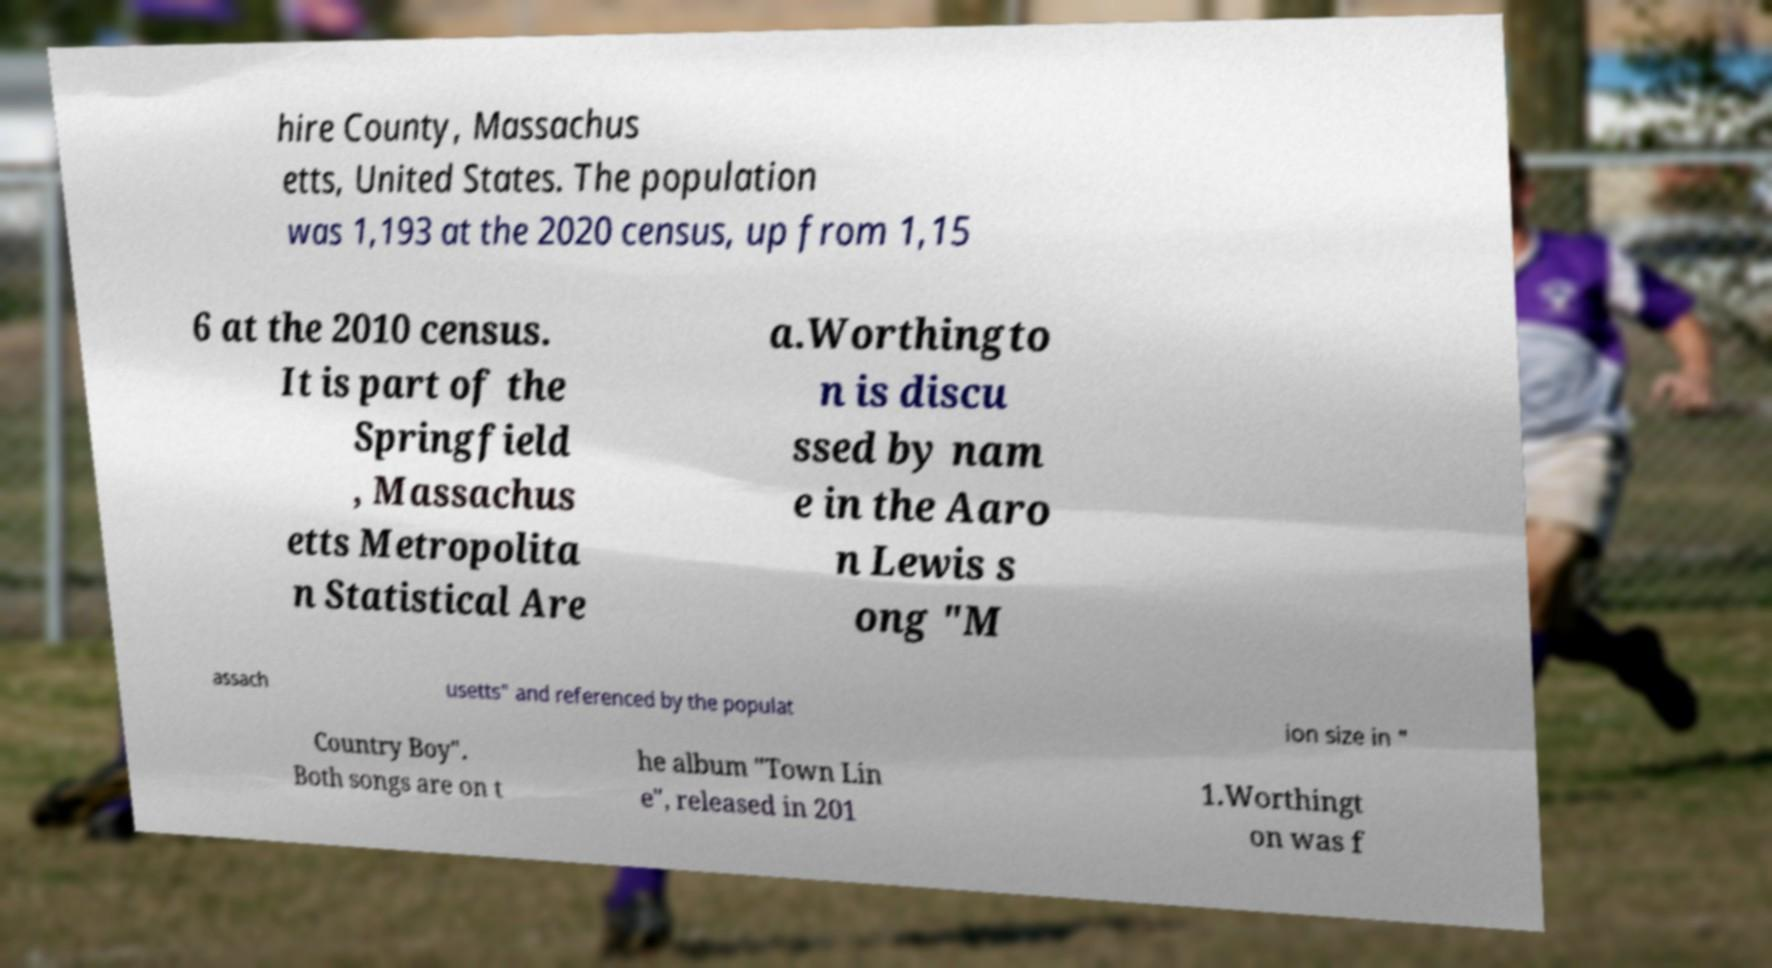Could you assist in decoding the text presented in this image and type it out clearly? hire County, Massachus etts, United States. The population was 1,193 at the 2020 census, up from 1,15 6 at the 2010 census. It is part of the Springfield , Massachus etts Metropolita n Statistical Are a.Worthingto n is discu ssed by nam e in the Aaro n Lewis s ong "M assach usetts" and referenced by the populat ion size in " Country Boy". Both songs are on t he album "Town Lin e", released in 201 1.Worthingt on was f 